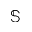Convert formula to latex. <formula><loc_0><loc_0><loc_500><loc_500>\mathbb { S }</formula> 